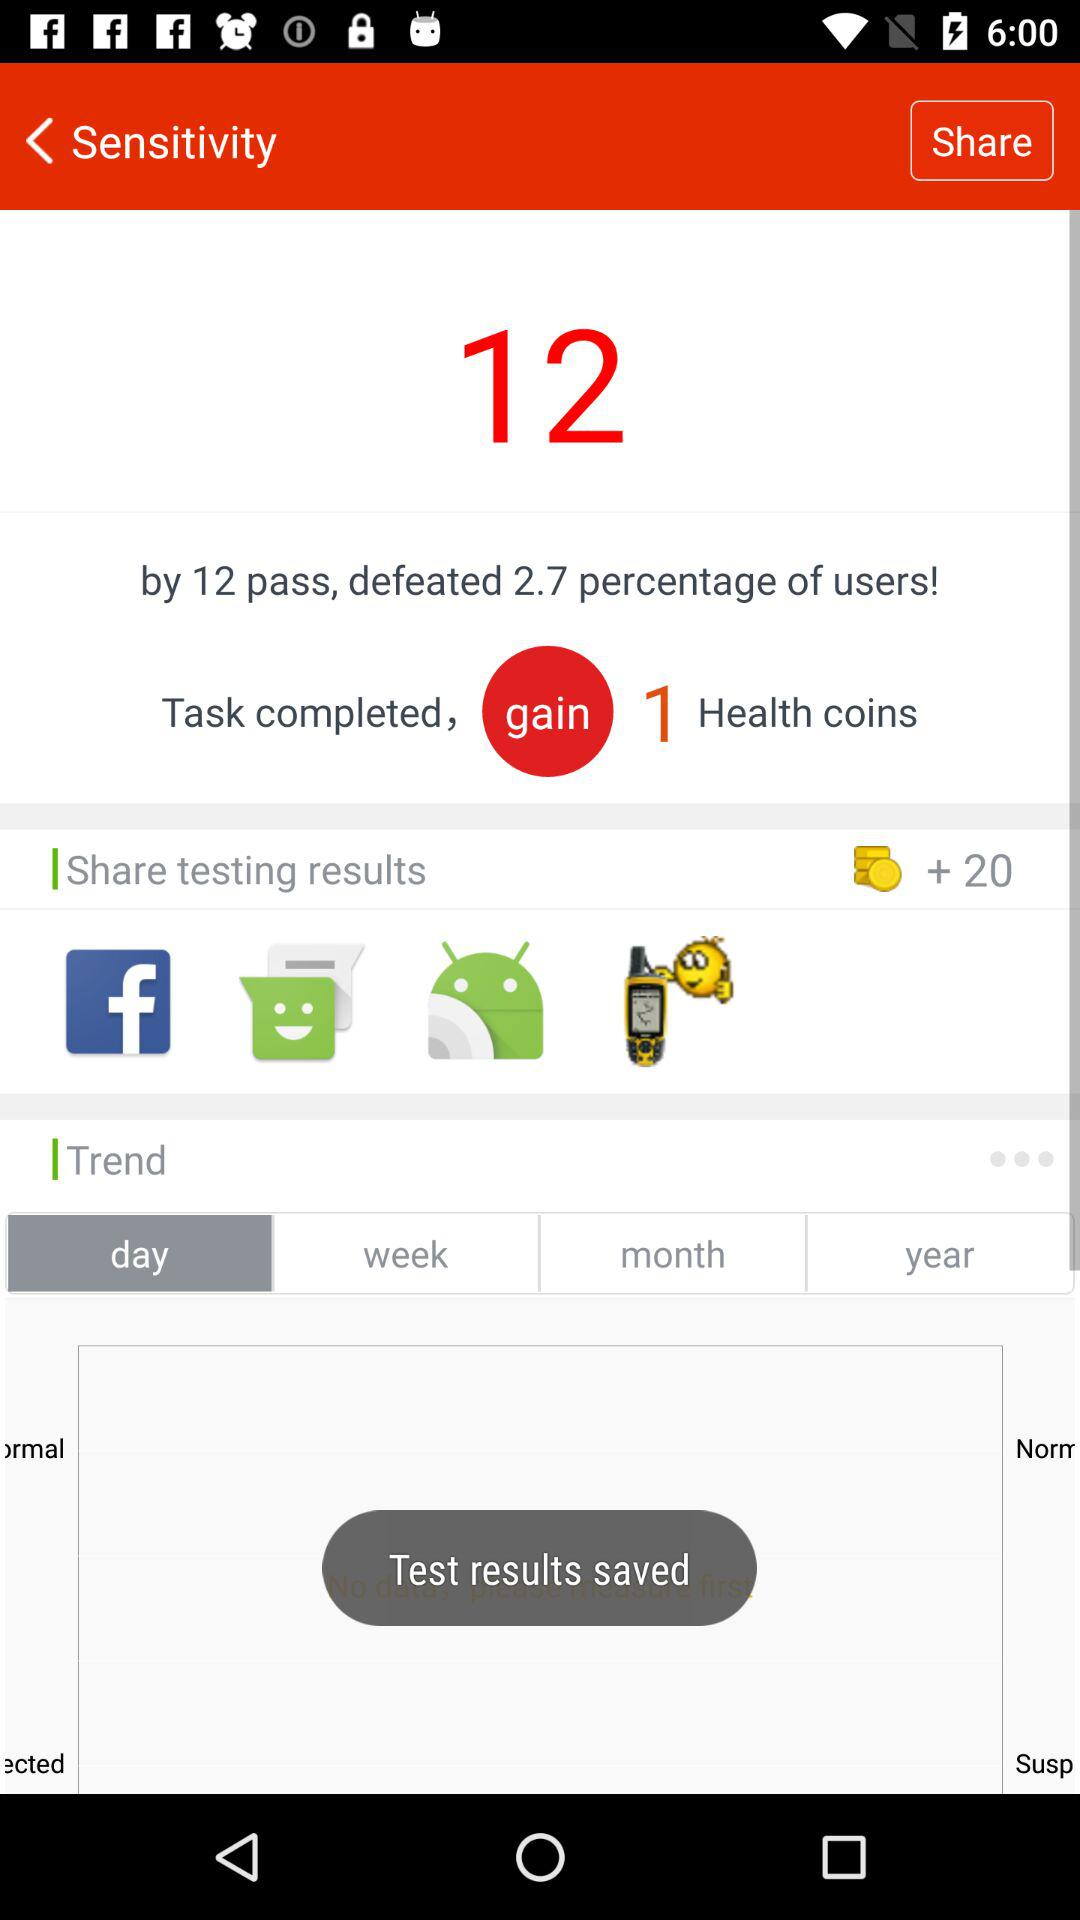What does the iconography in the 'Share testing results' section of the image suggest? The icons indicate different platforms where you can share your results. The 'f' likely stands for Facebook, the green icon suggests a messaging app like WhatsApp, and the Android robot points to a feature specific to Android devices. 